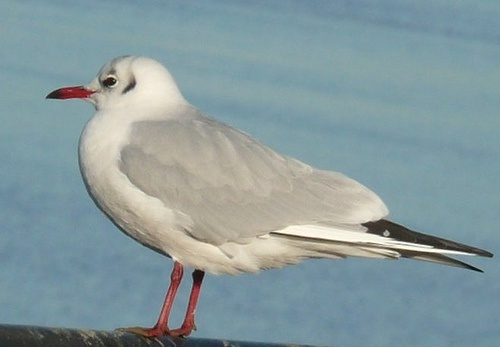Describe the objects in this image and their specific colors. I can see a bird in darkgray, beige, lightgray, and tan tones in this image. 